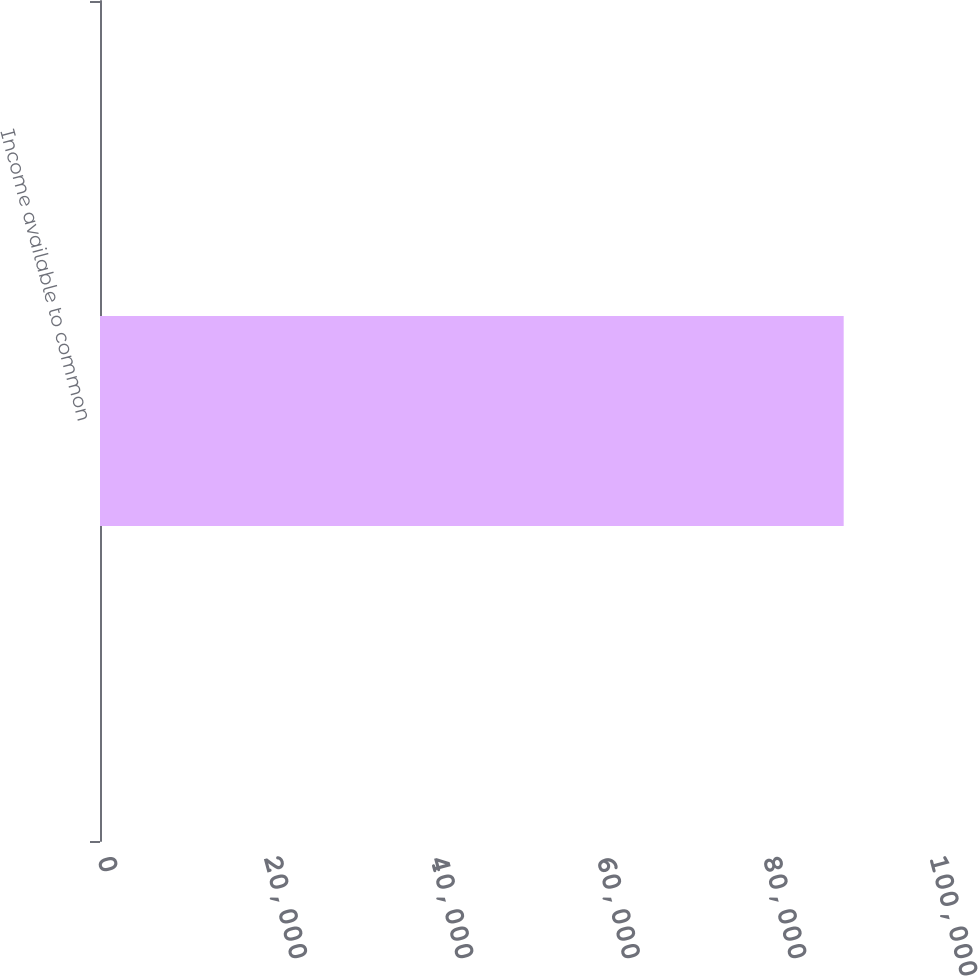Convert chart. <chart><loc_0><loc_0><loc_500><loc_500><bar_chart><fcel>Income available to common<nl><fcel>89385.1<nl></chart> 